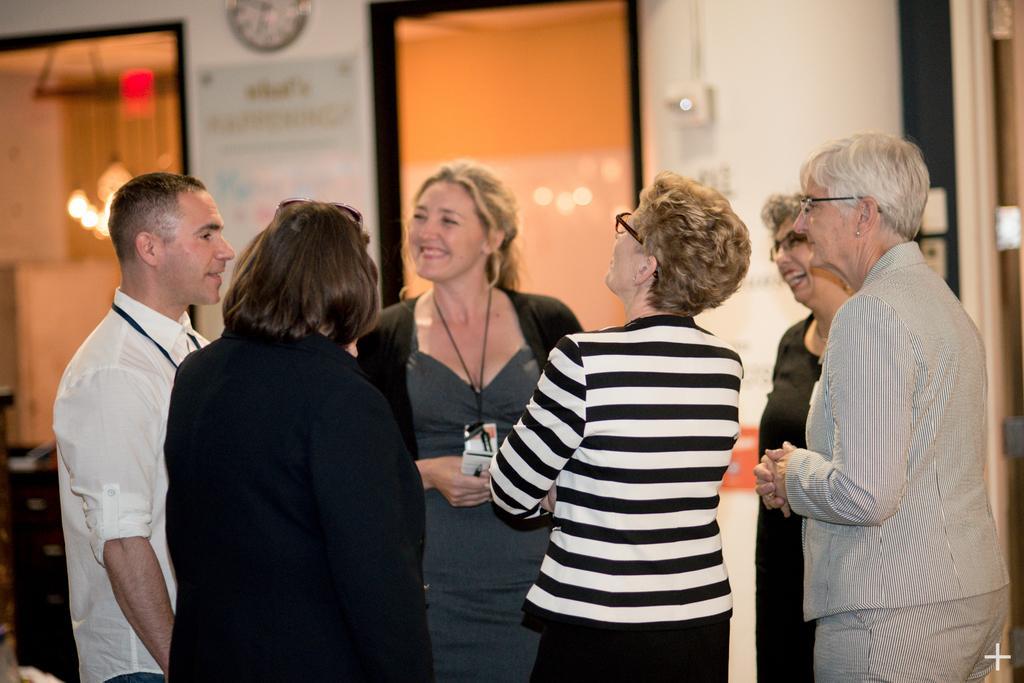Describe this image in one or two sentences. In this image we can see a few people standing, behind there is a wall clock, written text on the board, glass windows, lights. 